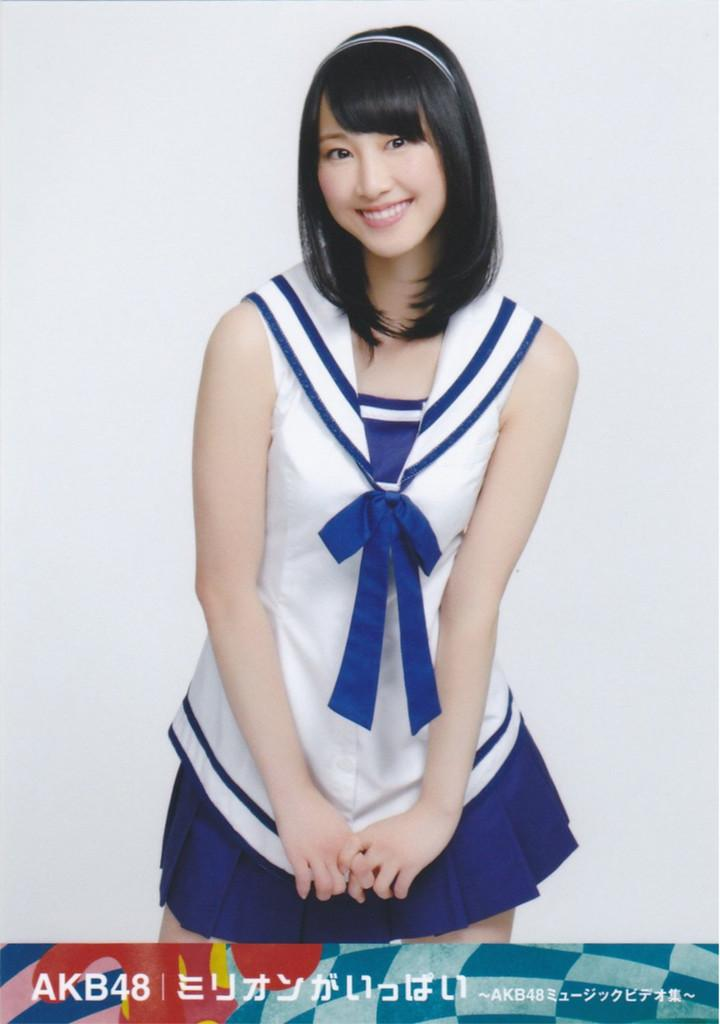<image>
Render a clear and concise summary of the photo. A woman in a blue and white silor outfit has the logo for AKB48 on the bottom. 